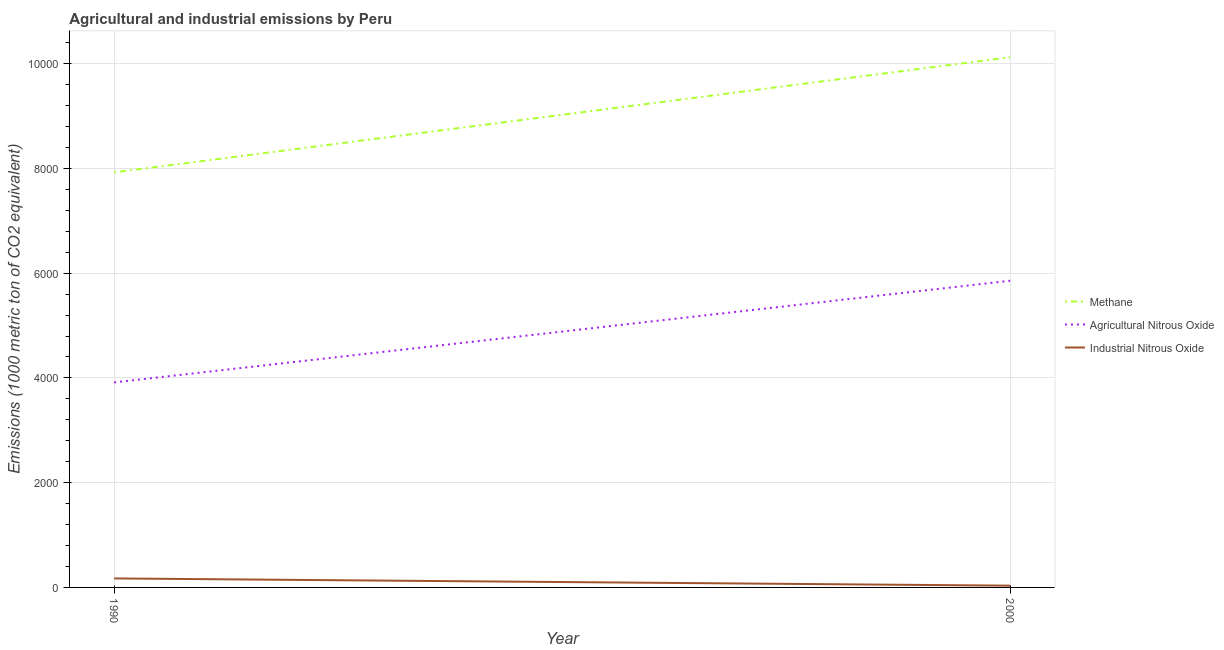How many different coloured lines are there?
Provide a succinct answer. 3. Does the line corresponding to amount of industrial nitrous oxide emissions intersect with the line corresponding to amount of methane emissions?
Your answer should be very brief. No. Is the number of lines equal to the number of legend labels?
Offer a terse response. Yes. What is the amount of methane emissions in 2000?
Offer a very short reply. 1.01e+04. Across all years, what is the maximum amount of methane emissions?
Provide a succinct answer. 1.01e+04. Across all years, what is the minimum amount of agricultural nitrous oxide emissions?
Your response must be concise. 3914.1. In which year was the amount of methane emissions maximum?
Make the answer very short. 2000. In which year was the amount of industrial nitrous oxide emissions minimum?
Keep it short and to the point. 2000. What is the total amount of industrial nitrous oxide emissions in the graph?
Your response must be concise. 205.4. What is the difference between the amount of industrial nitrous oxide emissions in 1990 and that in 2000?
Make the answer very short. 138.4. What is the difference between the amount of methane emissions in 1990 and the amount of agricultural nitrous oxide emissions in 2000?
Offer a very short reply. 2068.8. What is the average amount of methane emissions per year?
Offer a very short reply. 9022.8. In the year 2000, what is the difference between the amount of methane emissions and amount of agricultural nitrous oxide emissions?
Make the answer very short. 4267. In how many years, is the amount of industrial nitrous oxide emissions greater than 3200 metric ton?
Ensure brevity in your answer.  0. What is the ratio of the amount of industrial nitrous oxide emissions in 1990 to that in 2000?
Offer a very short reply. 5.13. Is the amount of methane emissions in 1990 less than that in 2000?
Offer a terse response. Yes. Does the amount of methane emissions monotonically increase over the years?
Provide a short and direct response. Yes. Is the amount of industrial nitrous oxide emissions strictly less than the amount of methane emissions over the years?
Your response must be concise. Yes. How many years are there in the graph?
Your answer should be compact. 2. What is the difference between two consecutive major ticks on the Y-axis?
Provide a succinct answer. 2000. Where does the legend appear in the graph?
Offer a terse response. Center right. How many legend labels are there?
Your answer should be very brief. 3. What is the title of the graph?
Ensure brevity in your answer.  Agricultural and industrial emissions by Peru. Does "Total employers" appear as one of the legend labels in the graph?
Your answer should be very brief. No. What is the label or title of the Y-axis?
Your response must be concise. Emissions (1000 metric ton of CO2 equivalent). What is the Emissions (1000 metric ton of CO2 equivalent) of Methane in 1990?
Your answer should be very brief. 7923.7. What is the Emissions (1000 metric ton of CO2 equivalent) of Agricultural Nitrous Oxide in 1990?
Keep it short and to the point. 3914.1. What is the Emissions (1000 metric ton of CO2 equivalent) in Industrial Nitrous Oxide in 1990?
Your response must be concise. 171.9. What is the Emissions (1000 metric ton of CO2 equivalent) in Methane in 2000?
Provide a short and direct response. 1.01e+04. What is the Emissions (1000 metric ton of CO2 equivalent) of Agricultural Nitrous Oxide in 2000?
Your answer should be compact. 5854.9. What is the Emissions (1000 metric ton of CO2 equivalent) of Industrial Nitrous Oxide in 2000?
Your response must be concise. 33.5. Across all years, what is the maximum Emissions (1000 metric ton of CO2 equivalent) in Methane?
Make the answer very short. 1.01e+04. Across all years, what is the maximum Emissions (1000 metric ton of CO2 equivalent) in Agricultural Nitrous Oxide?
Your answer should be very brief. 5854.9. Across all years, what is the maximum Emissions (1000 metric ton of CO2 equivalent) of Industrial Nitrous Oxide?
Give a very brief answer. 171.9. Across all years, what is the minimum Emissions (1000 metric ton of CO2 equivalent) in Methane?
Provide a succinct answer. 7923.7. Across all years, what is the minimum Emissions (1000 metric ton of CO2 equivalent) of Agricultural Nitrous Oxide?
Keep it short and to the point. 3914.1. Across all years, what is the minimum Emissions (1000 metric ton of CO2 equivalent) in Industrial Nitrous Oxide?
Offer a terse response. 33.5. What is the total Emissions (1000 metric ton of CO2 equivalent) in Methane in the graph?
Make the answer very short. 1.80e+04. What is the total Emissions (1000 metric ton of CO2 equivalent) of Agricultural Nitrous Oxide in the graph?
Ensure brevity in your answer.  9769. What is the total Emissions (1000 metric ton of CO2 equivalent) in Industrial Nitrous Oxide in the graph?
Offer a very short reply. 205.4. What is the difference between the Emissions (1000 metric ton of CO2 equivalent) of Methane in 1990 and that in 2000?
Keep it short and to the point. -2198.2. What is the difference between the Emissions (1000 metric ton of CO2 equivalent) in Agricultural Nitrous Oxide in 1990 and that in 2000?
Your response must be concise. -1940.8. What is the difference between the Emissions (1000 metric ton of CO2 equivalent) of Industrial Nitrous Oxide in 1990 and that in 2000?
Ensure brevity in your answer.  138.4. What is the difference between the Emissions (1000 metric ton of CO2 equivalent) in Methane in 1990 and the Emissions (1000 metric ton of CO2 equivalent) in Agricultural Nitrous Oxide in 2000?
Your answer should be very brief. 2068.8. What is the difference between the Emissions (1000 metric ton of CO2 equivalent) in Methane in 1990 and the Emissions (1000 metric ton of CO2 equivalent) in Industrial Nitrous Oxide in 2000?
Make the answer very short. 7890.2. What is the difference between the Emissions (1000 metric ton of CO2 equivalent) in Agricultural Nitrous Oxide in 1990 and the Emissions (1000 metric ton of CO2 equivalent) in Industrial Nitrous Oxide in 2000?
Offer a very short reply. 3880.6. What is the average Emissions (1000 metric ton of CO2 equivalent) of Methane per year?
Keep it short and to the point. 9022.8. What is the average Emissions (1000 metric ton of CO2 equivalent) of Agricultural Nitrous Oxide per year?
Offer a terse response. 4884.5. What is the average Emissions (1000 metric ton of CO2 equivalent) of Industrial Nitrous Oxide per year?
Keep it short and to the point. 102.7. In the year 1990, what is the difference between the Emissions (1000 metric ton of CO2 equivalent) in Methane and Emissions (1000 metric ton of CO2 equivalent) in Agricultural Nitrous Oxide?
Your answer should be compact. 4009.6. In the year 1990, what is the difference between the Emissions (1000 metric ton of CO2 equivalent) in Methane and Emissions (1000 metric ton of CO2 equivalent) in Industrial Nitrous Oxide?
Provide a short and direct response. 7751.8. In the year 1990, what is the difference between the Emissions (1000 metric ton of CO2 equivalent) in Agricultural Nitrous Oxide and Emissions (1000 metric ton of CO2 equivalent) in Industrial Nitrous Oxide?
Provide a short and direct response. 3742.2. In the year 2000, what is the difference between the Emissions (1000 metric ton of CO2 equivalent) of Methane and Emissions (1000 metric ton of CO2 equivalent) of Agricultural Nitrous Oxide?
Ensure brevity in your answer.  4267. In the year 2000, what is the difference between the Emissions (1000 metric ton of CO2 equivalent) in Methane and Emissions (1000 metric ton of CO2 equivalent) in Industrial Nitrous Oxide?
Ensure brevity in your answer.  1.01e+04. In the year 2000, what is the difference between the Emissions (1000 metric ton of CO2 equivalent) in Agricultural Nitrous Oxide and Emissions (1000 metric ton of CO2 equivalent) in Industrial Nitrous Oxide?
Give a very brief answer. 5821.4. What is the ratio of the Emissions (1000 metric ton of CO2 equivalent) of Methane in 1990 to that in 2000?
Your answer should be very brief. 0.78. What is the ratio of the Emissions (1000 metric ton of CO2 equivalent) in Agricultural Nitrous Oxide in 1990 to that in 2000?
Provide a succinct answer. 0.67. What is the ratio of the Emissions (1000 metric ton of CO2 equivalent) of Industrial Nitrous Oxide in 1990 to that in 2000?
Offer a terse response. 5.13. What is the difference between the highest and the second highest Emissions (1000 metric ton of CO2 equivalent) of Methane?
Ensure brevity in your answer.  2198.2. What is the difference between the highest and the second highest Emissions (1000 metric ton of CO2 equivalent) in Agricultural Nitrous Oxide?
Keep it short and to the point. 1940.8. What is the difference between the highest and the second highest Emissions (1000 metric ton of CO2 equivalent) of Industrial Nitrous Oxide?
Make the answer very short. 138.4. What is the difference between the highest and the lowest Emissions (1000 metric ton of CO2 equivalent) of Methane?
Ensure brevity in your answer.  2198.2. What is the difference between the highest and the lowest Emissions (1000 metric ton of CO2 equivalent) in Agricultural Nitrous Oxide?
Provide a short and direct response. 1940.8. What is the difference between the highest and the lowest Emissions (1000 metric ton of CO2 equivalent) in Industrial Nitrous Oxide?
Keep it short and to the point. 138.4. 